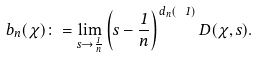<formula> <loc_0><loc_0><loc_500><loc_500>b _ { n } ( \chi ) \colon = \lim _ { s \to \frac { 1 } { n } } \left ( s - \frac { 1 } { n } \right ) ^ { d _ { n } ( \ 1 ) } D ( \chi , s ) .</formula> 